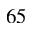Convert formula to latex. <formula><loc_0><loc_0><loc_500><loc_500>^ { 6 } 5</formula> 